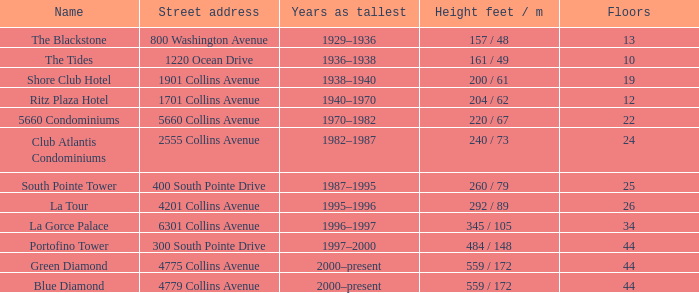What is the total number of floors in the blue diamond? 44.0. 